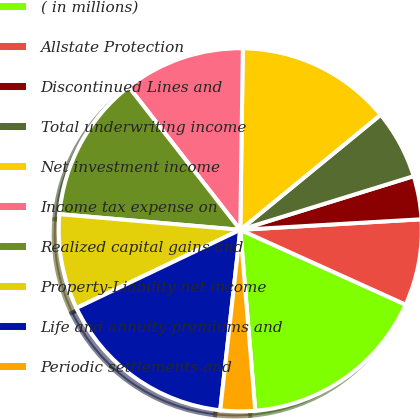Convert chart to OTSL. <chart><loc_0><loc_0><loc_500><loc_500><pie_chart><fcel>( in millions)<fcel>Allstate Protection<fcel>Discontinued Lines and<fcel>Total underwriting income<fcel>Net investment income<fcel>Income tax expense on<fcel>Realized capital gains and<fcel>Property-Liability net income<fcel>Life and annuity premiums and<fcel>Periodic settlements and<nl><fcel>16.92%<fcel>7.69%<fcel>3.85%<fcel>6.15%<fcel>13.85%<fcel>10.77%<fcel>13.08%<fcel>8.46%<fcel>16.15%<fcel>3.08%<nl></chart> 